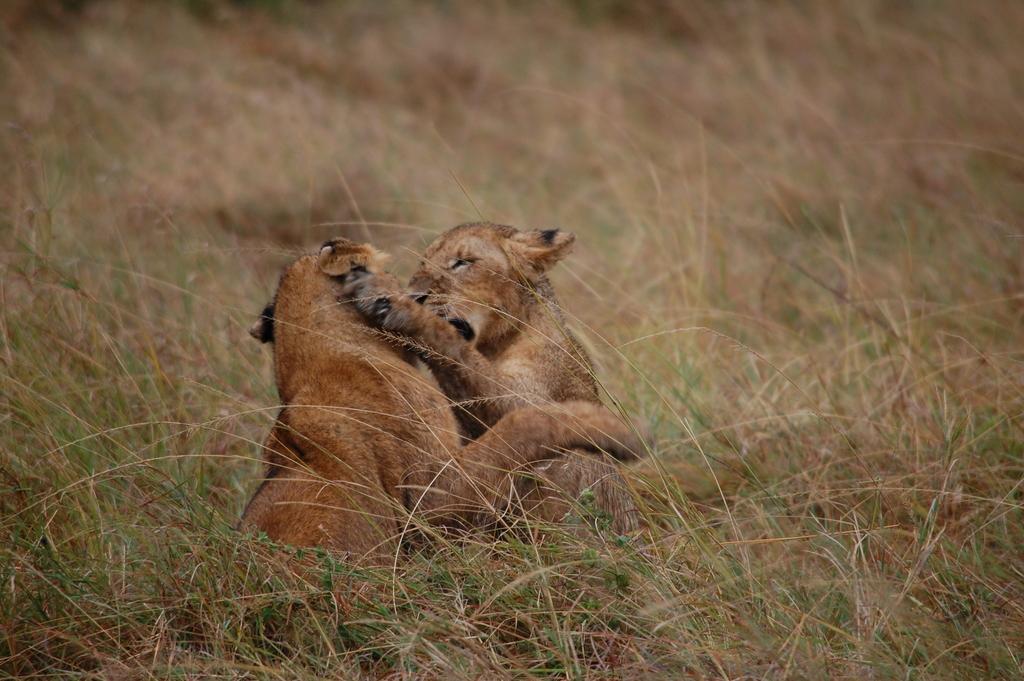Please provide a concise description of this image. In the center of the image, we can see animals and at the bottom, there is ground, covered with grass. 